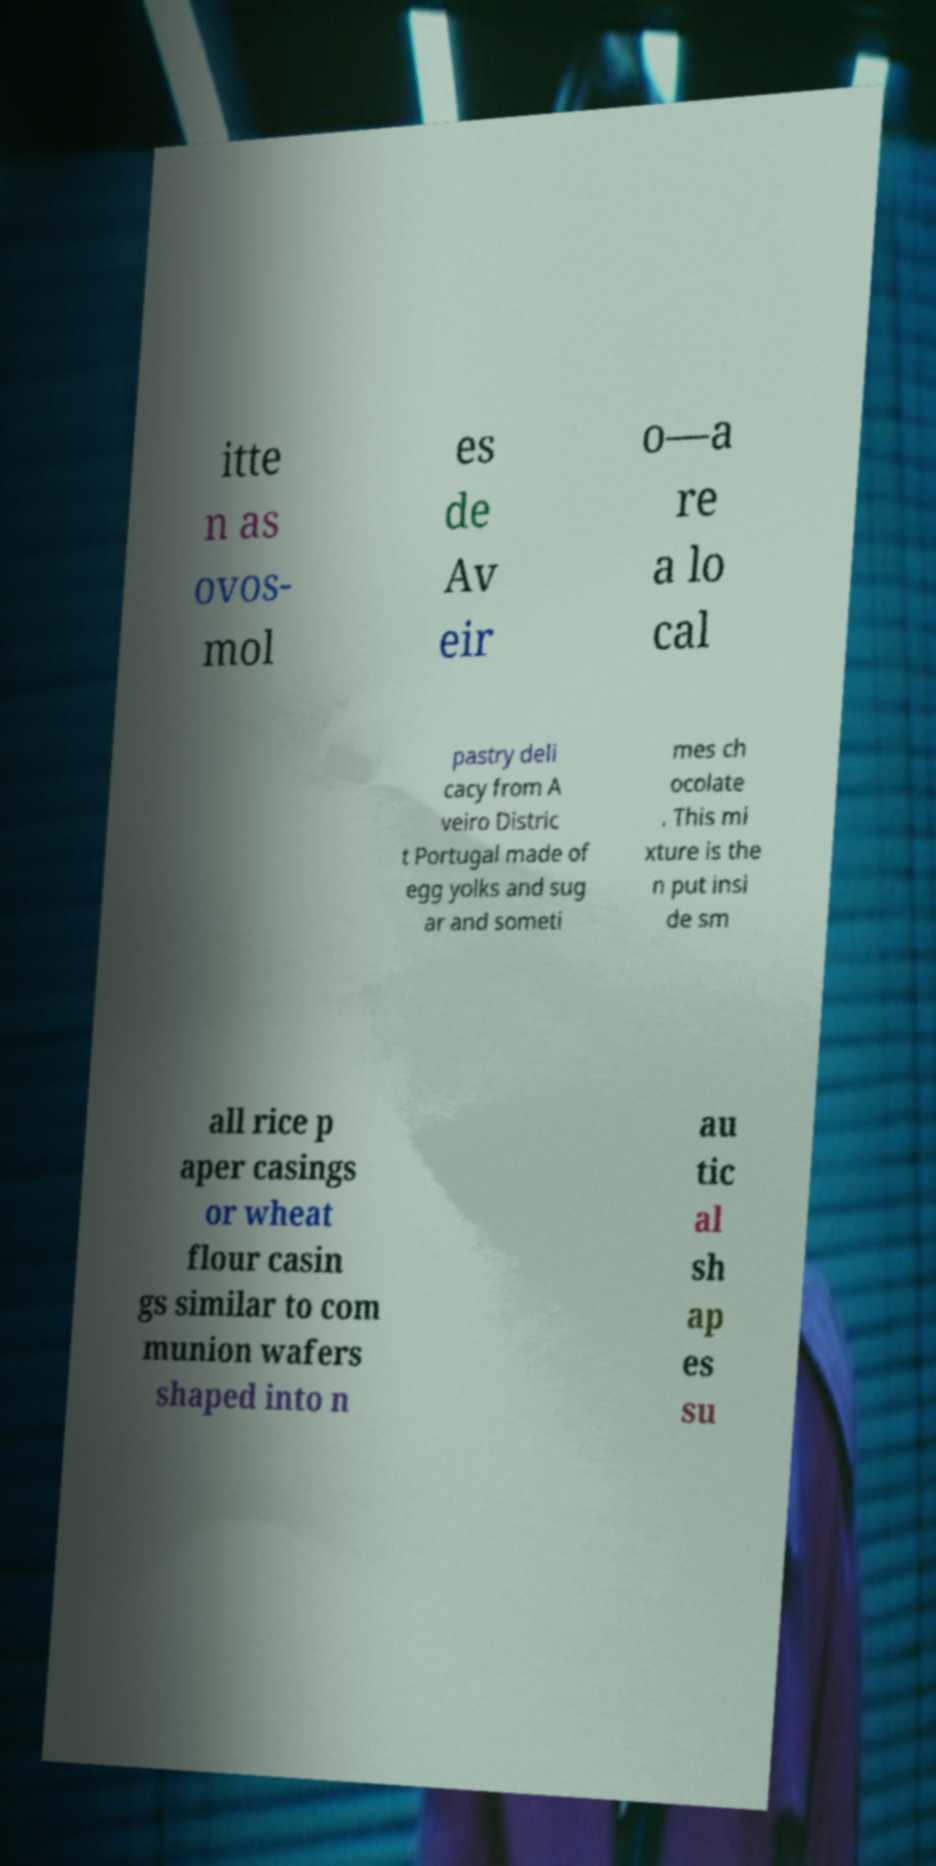Please identify and transcribe the text found in this image. itte n as ovos- mol es de Av eir o—a re a lo cal pastry deli cacy from A veiro Distric t Portugal made of egg yolks and sug ar and someti mes ch ocolate . This mi xture is the n put insi de sm all rice p aper casings or wheat flour casin gs similar to com munion wafers shaped into n au tic al sh ap es su 